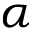<formula> <loc_0><loc_0><loc_500><loc_500>\alpha</formula> 